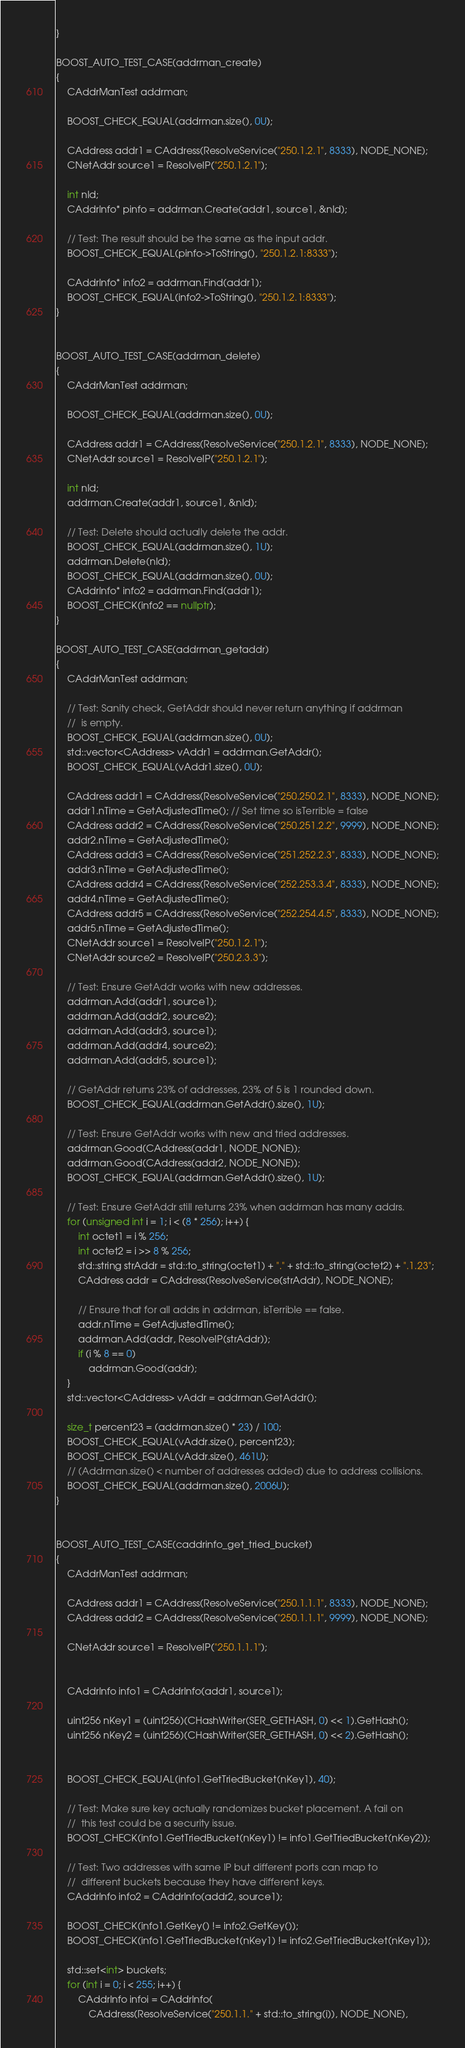Convert code to text. <code><loc_0><loc_0><loc_500><loc_500><_C++_>}

BOOST_AUTO_TEST_CASE(addrman_create)
{
    CAddrManTest addrman;

    BOOST_CHECK_EQUAL(addrman.size(), 0U);

    CAddress addr1 = CAddress(ResolveService("250.1.2.1", 8333), NODE_NONE);
    CNetAddr source1 = ResolveIP("250.1.2.1");

    int nId;
    CAddrInfo* pinfo = addrman.Create(addr1, source1, &nId);

    // Test: The result should be the same as the input addr.
    BOOST_CHECK_EQUAL(pinfo->ToString(), "250.1.2.1:8333");

    CAddrInfo* info2 = addrman.Find(addr1);
    BOOST_CHECK_EQUAL(info2->ToString(), "250.1.2.1:8333");
}


BOOST_AUTO_TEST_CASE(addrman_delete)
{
    CAddrManTest addrman;

    BOOST_CHECK_EQUAL(addrman.size(), 0U);

    CAddress addr1 = CAddress(ResolveService("250.1.2.1", 8333), NODE_NONE);
    CNetAddr source1 = ResolveIP("250.1.2.1");

    int nId;
    addrman.Create(addr1, source1, &nId);

    // Test: Delete should actually delete the addr.
    BOOST_CHECK_EQUAL(addrman.size(), 1U);
    addrman.Delete(nId);
    BOOST_CHECK_EQUAL(addrman.size(), 0U);
    CAddrInfo* info2 = addrman.Find(addr1);
    BOOST_CHECK(info2 == nullptr);
}

BOOST_AUTO_TEST_CASE(addrman_getaddr)
{
    CAddrManTest addrman;

    // Test: Sanity check, GetAddr should never return anything if addrman
    //  is empty.
    BOOST_CHECK_EQUAL(addrman.size(), 0U);
    std::vector<CAddress> vAddr1 = addrman.GetAddr();
    BOOST_CHECK_EQUAL(vAddr1.size(), 0U);

    CAddress addr1 = CAddress(ResolveService("250.250.2.1", 8333), NODE_NONE);
    addr1.nTime = GetAdjustedTime(); // Set time so isTerrible = false
    CAddress addr2 = CAddress(ResolveService("250.251.2.2", 9999), NODE_NONE);
    addr2.nTime = GetAdjustedTime();
    CAddress addr3 = CAddress(ResolveService("251.252.2.3", 8333), NODE_NONE);
    addr3.nTime = GetAdjustedTime();
    CAddress addr4 = CAddress(ResolveService("252.253.3.4", 8333), NODE_NONE);
    addr4.nTime = GetAdjustedTime();
    CAddress addr5 = CAddress(ResolveService("252.254.4.5", 8333), NODE_NONE);
    addr5.nTime = GetAdjustedTime();
    CNetAddr source1 = ResolveIP("250.1.2.1");
    CNetAddr source2 = ResolveIP("250.2.3.3");

    // Test: Ensure GetAddr works with new addresses.
    addrman.Add(addr1, source1);
    addrman.Add(addr2, source2);
    addrman.Add(addr3, source1);
    addrman.Add(addr4, source2);
    addrman.Add(addr5, source1);

    // GetAddr returns 23% of addresses, 23% of 5 is 1 rounded down.
    BOOST_CHECK_EQUAL(addrman.GetAddr().size(), 1U);

    // Test: Ensure GetAddr works with new and tried addresses.
    addrman.Good(CAddress(addr1, NODE_NONE));
    addrman.Good(CAddress(addr2, NODE_NONE));
    BOOST_CHECK_EQUAL(addrman.GetAddr().size(), 1U);

    // Test: Ensure GetAddr still returns 23% when addrman has many addrs.
    for (unsigned int i = 1; i < (8 * 256); i++) {
        int octet1 = i % 256;
        int octet2 = i >> 8 % 256;
        std::string strAddr = std::to_string(octet1) + "." + std::to_string(octet2) + ".1.23";
        CAddress addr = CAddress(ResolveService(strAddr), NODE_NONE);

        // Ensure that for all addrs in addrman, isTerrible == false.
        addr.nTime = GetAdjustedTime();
        addrman.Add(addr, ResolveIP(strAddr));
        if (i % 8 == 0)
            addrman.Good(addr);
    }
    std::vector<CAddress> vAddr = addrman.GetAddr();

    size_t percent23 = (addrman.size() * 23) / 100;
    BOOST_CHECK_EQUAL(vAddr.size(), percent23);
    BOOST_CHECK_EQUAL(vAddr.size(), 461U);
    // (Addrman.size() < number of addresses added) due to address collisions.
    BOOST_CHECK_EQUAL(addrman.size(), 2006U);
}


BOOST_AUTO_TEST_CASE(caddrinfo_get_tried_bucket)
{
    CAddrManTest addrman;

    CAddress addr1 = CAddress(ResolveService("250.1.1.1", 8333), NODE_NONE);
    CAddress addr2 = CAddress(ResolveService("250.1.1.1", 9999), NODE_NONE);

    CNetAddr source1 = ResolveIP("250.1.1.1");


    CAddrInfo info1 = CAddrInfo(addr1, source1);

    uint256 nKey1 = (uint256)(CHashWriter(SER_GETHASH, 0) << 1).GetHash();
    uint256 nKey2 = (uint256)(CHashWriter(SER_GETHASH, 0) << 2).GetHash();


    BOOST_CHECK_EQUAL(info1.GetTriedBucket(nKey1), 40);

    // Test: Make sure key actually randomizes bucket placement. A fail on
    //  this test could be a security issue.
    BOOST_CHECK(info1.GetTriedBucket(nKey1) != info1.GetTriedBucket(nKey2));

    // Test: Two addresses with same IP but different ports can map to
    //  different buckets because they have different keys.
    CAddrInfo info2 = CAddrInfo(addr2, source1);

    BOOST_CHECK(info1.GetKey() != info2.GetKey());
    BOOST_CHECK(info1.GetTriedBucket(nKey1) != info2.GetTriedBucket(nKey1));

    std::set<int> buckets;
    for (int i = 0; i < 255; i++) {
        CAddrInfo infoi = CAddrInfo(
            CAddress(ResolveService("250.1.1." + std::to_string(i)), NODE_NONE),</code> 